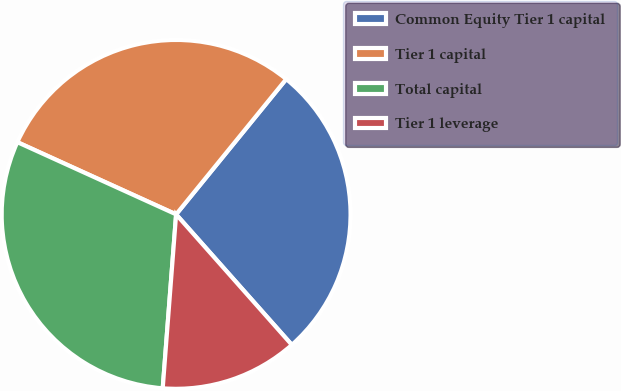Convert chart to OTSL. <chart><loc_0><loc_0><loc_500><loc_500><pie_chart><fcel>Common Equity Tier 1 capital<fcel>Tier 1 capital<fcel>Total capital<fcel>Tier 1 leverage<nl><fcel>27.58%<fcel>29.08%<fcel>30.57%<fcel>12.77%<nl></chart> 